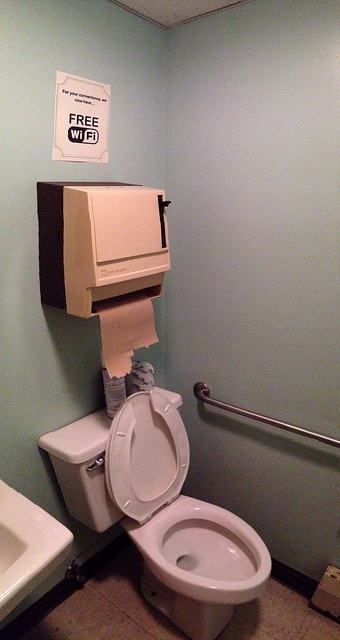Describe the objects in this image and their specific colors. I can see toilet in darkgray, lightpink, black, and maroon tones and sink in darkgray, tan, black, and pink tones in this image. 